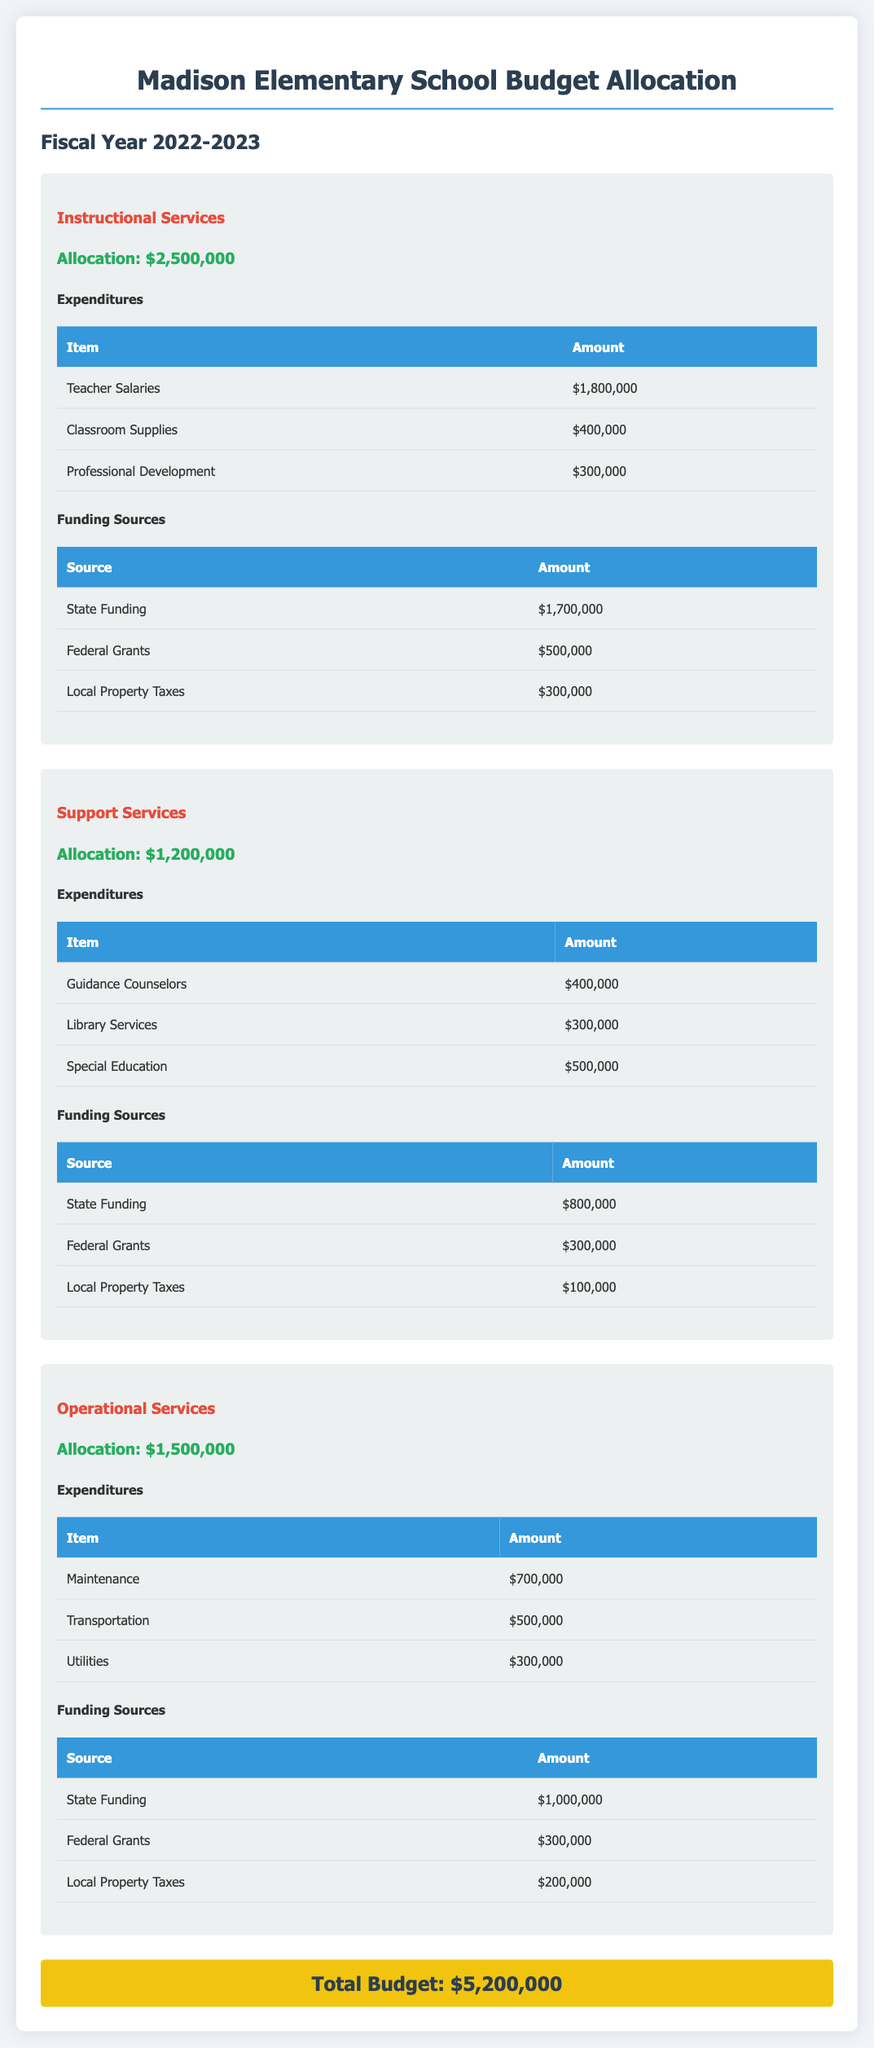What is the total budget for Madison Elementary School? The total budget is stated at the end of the document and is the overall allocation for the fiscal year.
Answer: $5,200,000 How much is allocated for Instructional Services? The allocation for Instructional Services is listed in the corresponding section and reflects the budget set aside for this department.
Answer: $2,500,000 What is the amount for Teacher Salaries? Teacher Salaries are specified under the expenditures for Instructional Services, indicating how much is allocated for this expense.
Answer: $1,800,000 Which funding source contributes the most to Support Services? The funding sources are listed with their respective amounts, showing which source provides the highest funding for this category.
Answer: State Funding How much is allocated for Special Education under Support Services? Special Education's allocation is part of the expenditures under Support Services, showing the designated funds for this category.
Answer: $500,000 What is the total amount from Local Property Taxes for all departments? To find this, you must sum the Local Property Taxes listed under each department's funding sources.
Answer: $600,000 Which department has the highest allocation? The departments' allocations are compared, helping to identify which one has received the most funds for the fiscal year.
Answer: Instructional Services How much is spent on Utilities in Operational Services? The expenditure for Utilities is explicitly mentioned under Operational Services, showing operational costs for this area.
Answer: $300,000 What are the federal grants for Support Services? The federal grants listed show the amount allocated to Support Services, which is separate from state or local funding.
Answer: $300,000 